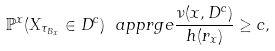<formula> <loc_0><loc_0><loc_500><loc_500>\mathbb { P } ^ { x } ( X _ { \tau _ { B _ { x } } } \in D ^ { c } ) \ a p p r g e \frac { \nu ( x , D ^ { c } ) } { h ( r _ { x } ) } \geq c ,</formula> 